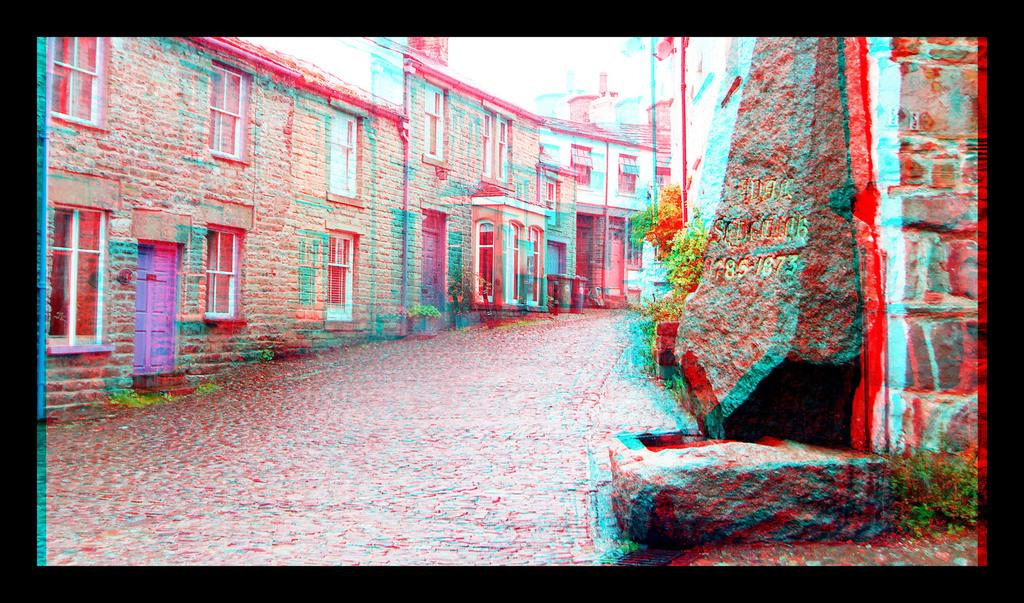What is covering the road in the image? There is water on the road in the image. What can be seen on both sides of the road? There are buildings on either side of the road in the image. How does the passenger feel about the twist in the road in the image? There is no passenger or twist in the road present in the image. 